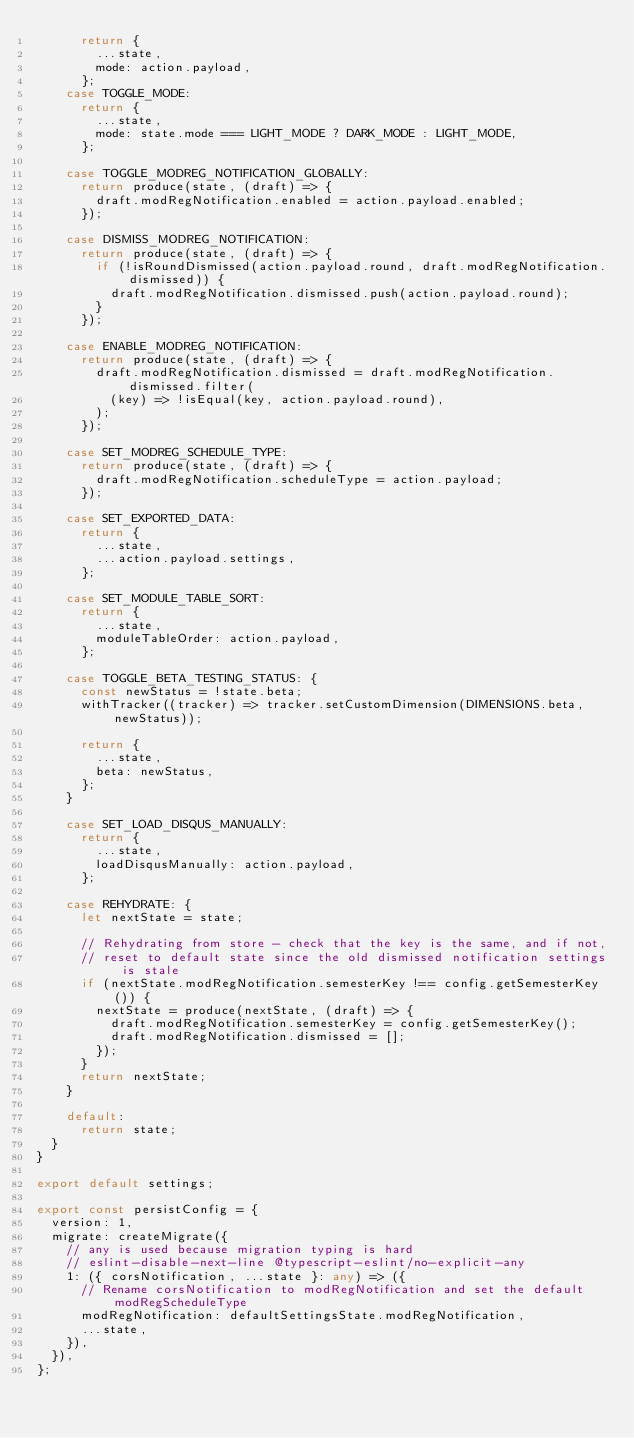Convert code to text. <code><loc_0><loc_0><loc_500><loc_500><_TypeScript_>      return {
        ...state,
        mode: action.payload,
      };
    case TOGGLE_MODE:
      return {
        ...state,
        mode: state.mode === LIGHT_MODE ? DARK_MODE : LIGHT_MODE,
      };

    case TOGGLE_MODREG_NOTIFICATION_GLOBALLY:
      return produce(state, (draft) => {
        draft.modRegNotification.enabled = action.payload.enabled;
      });

    case DISMISS_MODREG_NOTIFICATION:
      return produce(state, (draft) => {
        if (!isRoundDismissed(action.payload.round, draft.modRegNotification.dismissed)) {
          draft.modRegNotification.dismissed.push(action.payload.round);
        }
      });

    case ENABLE_MODREG_NOTIFICATION:
      return produce(state, (draft) => {
        draft.modRegNotification.dismissed = draft.modRegNotification.dismissed.filter(
          (key) => !isEqual(key, action.payload.round),
        );
      });

    case SET_MODREG_SCHEDULE_TYPE:
      return produce(state, (draft) => {
        draft.modRegNotification.scheduleType = action.payload;
      });

    case SET_EXPORTED_DATA:
      return {
        ...state,
        ...action.payload.settings,
      };

    case SET_MODULE_TABLE_SORT:
      return {
        ...state,
        moduleTableOrder: action.payload,
      };

    case TOGGLE_BETA_TESTING_STATUS: {
      const newStatus = !state.beta;
      withTracker((tracker) => tracker.setCustomDimension(DIMENSIONS.beta, newStatus));

      return {
        ...state,
        beta: newStatus,
      };
    }

    case SET_LOAD_DISQUS_MANUALLY:
      return {
        ...state,
        loadDisqusManually: action.payload,
      };

    case REHYDRATE: {
      let nextState = state;

      // Rehydrating from store - check that the key is the same, and if not,
      // reset to default state since the old dismissed notification settings is stale
      if (nextState.modRegNotification.semesterKey !== config.getSemesterKey()) {
        nextState = produce(nextState, (draft) => {
          draft.modRegNotification.semesterKey = config.getSemesterKey();
          draft.modRegNotification.dismissed = [];
        });
      }
      return nextState;
    }

    default:
      return state;
  }
}

export default settings;

export const persistConfig = {
  version: 1,
  migrate: createMigrate({
    // any is used because migration typing is hard
    // eslint-disable-next-line @typescript-eslint/no-explicit-any
    1: ({ corsNotification, ...state }: any) => ({
      // Rename corsNotification to modRegNotification and set the default modRegScheduleType
      modRegNotification: defaultSettingsState.modRegNotification,
      ...state,
    }),
  }),
};
</code> 